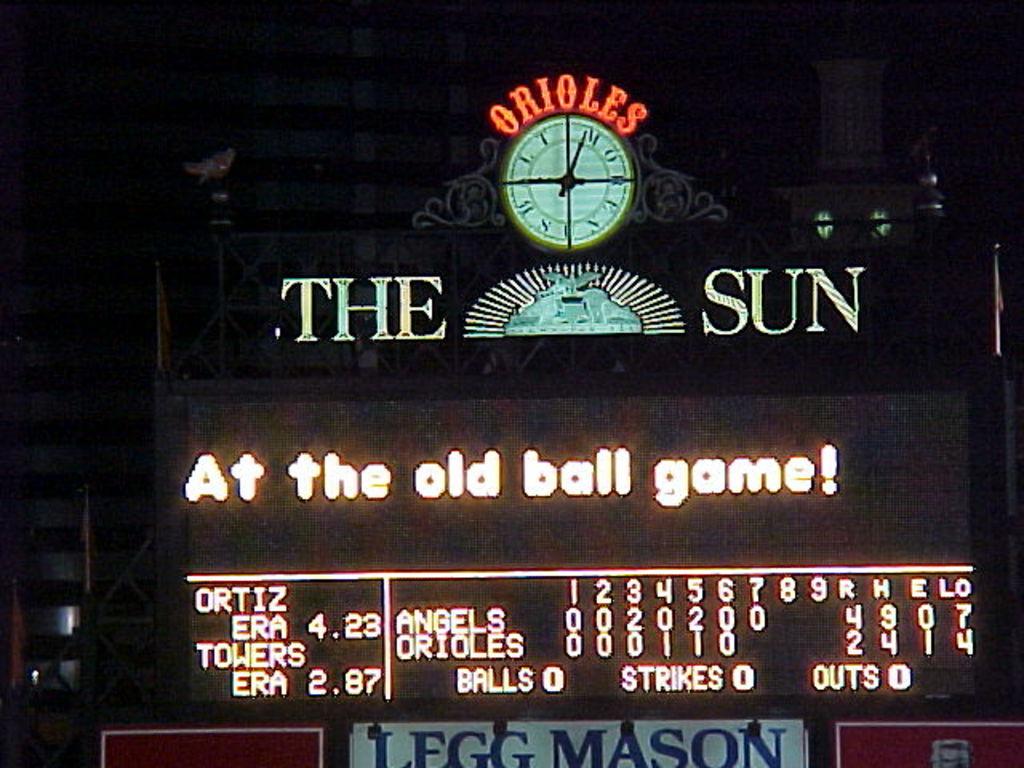What are the two words under the clock?
Keep it short and to the point. The sun. 